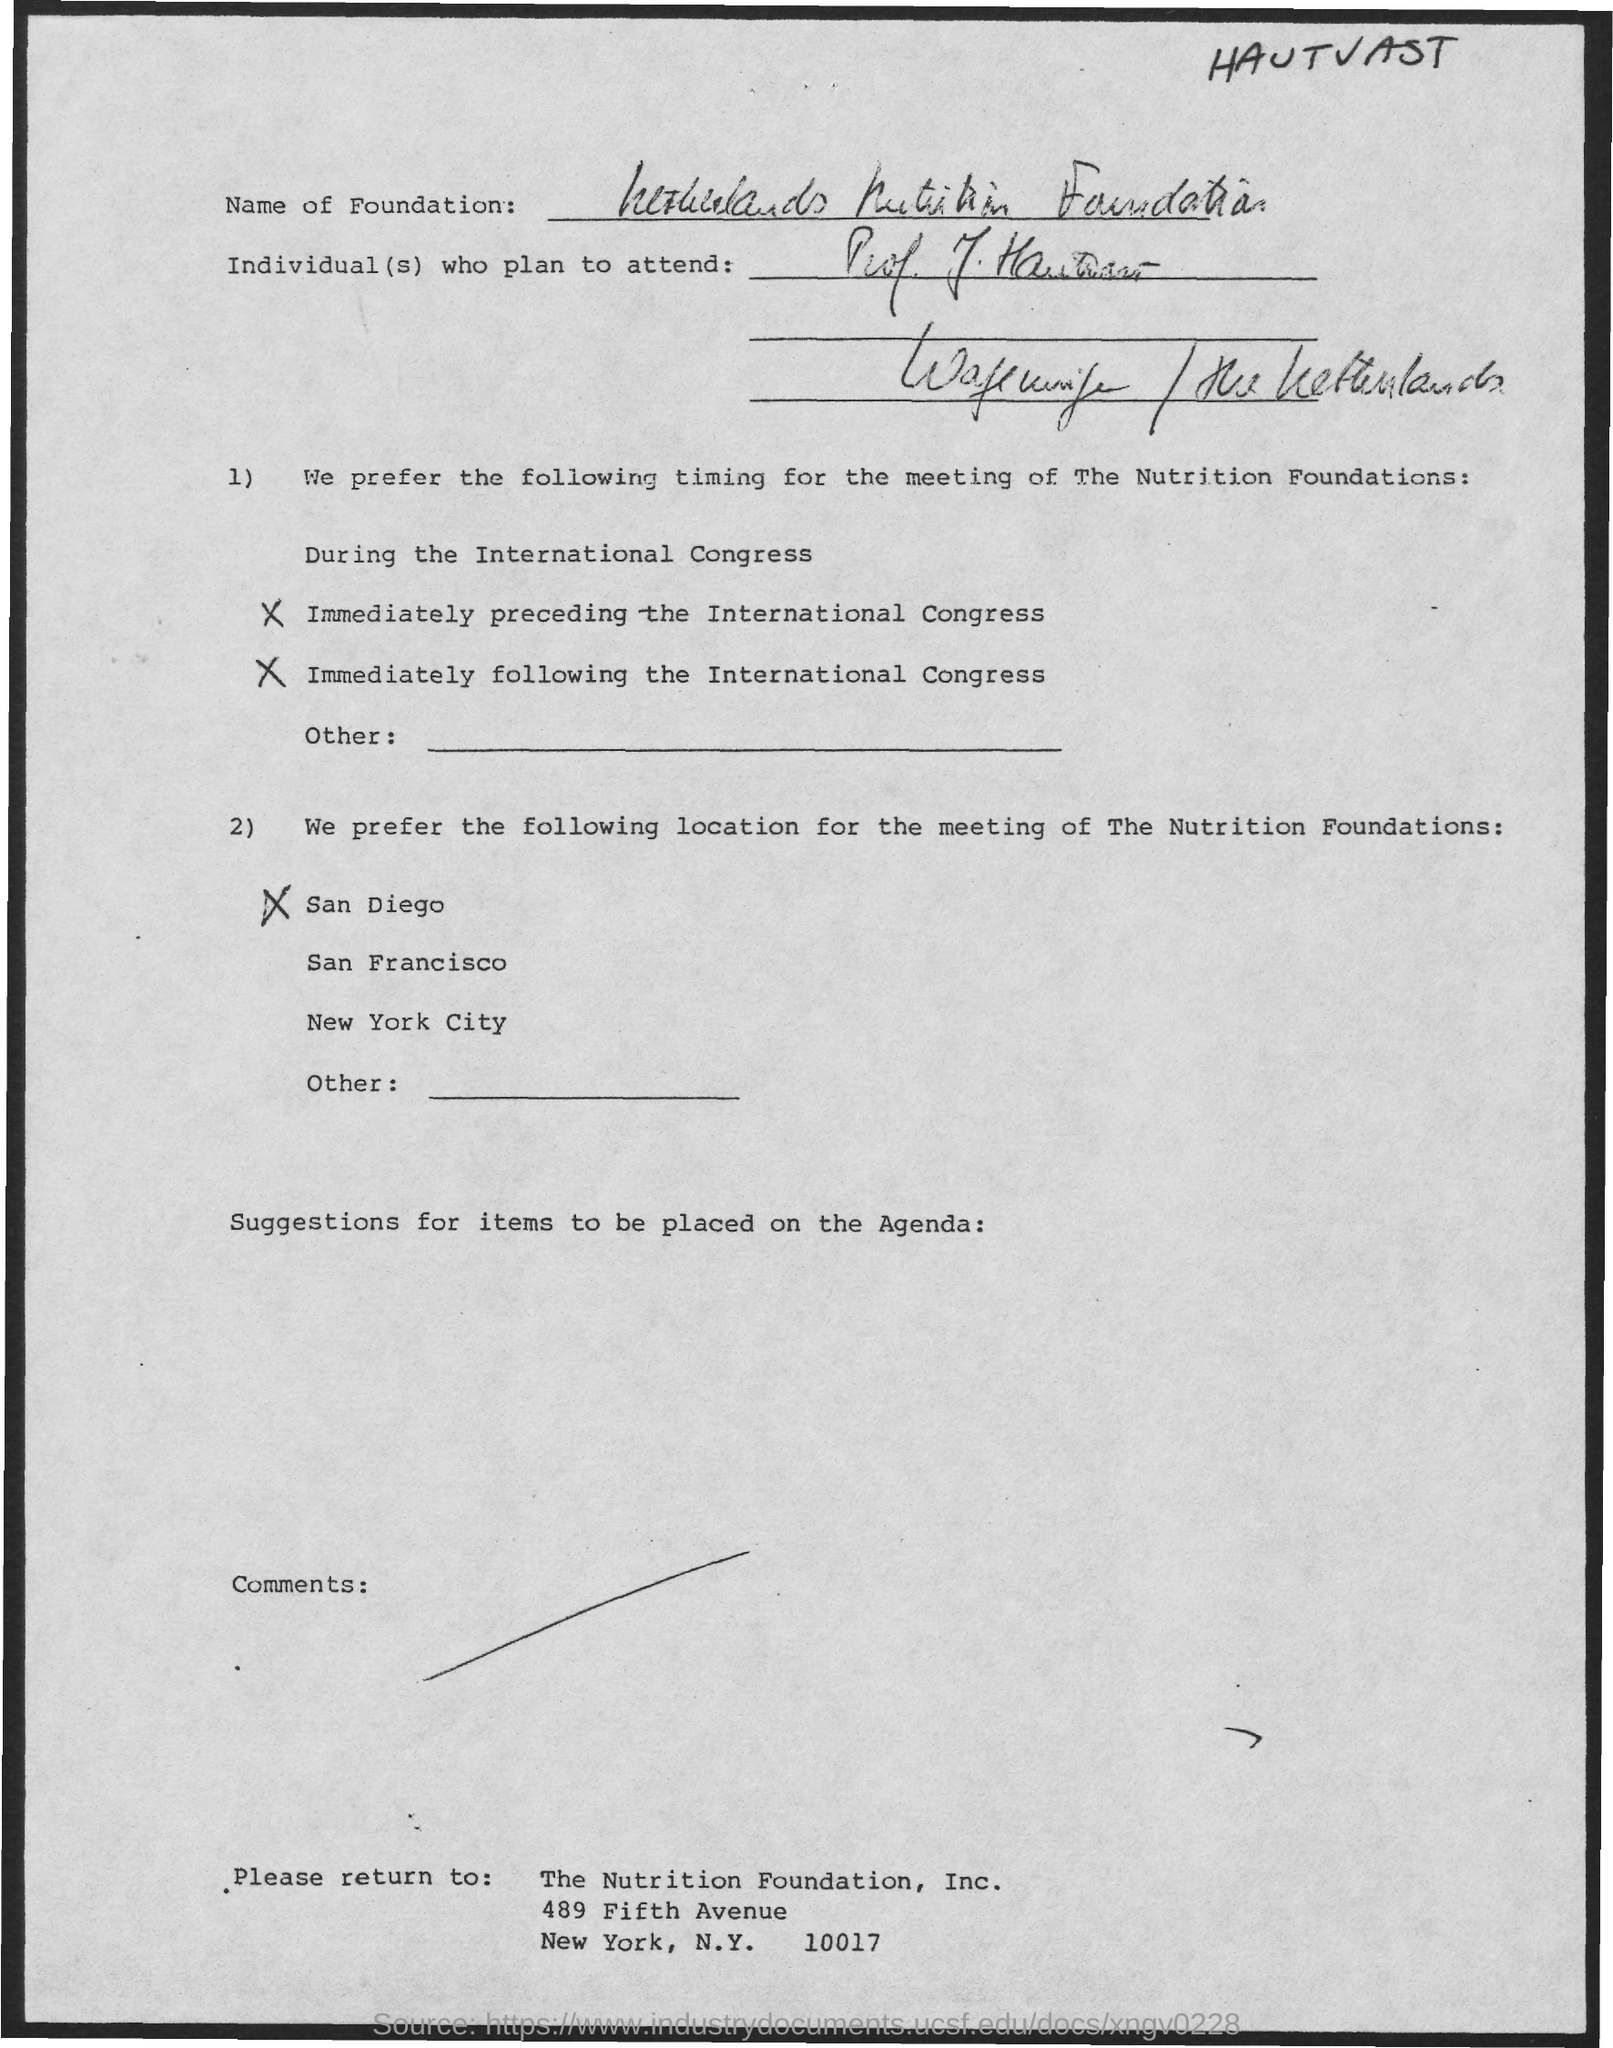To whom this has to be returned ?
Provide a succinct answer. The Nutrition Foundation, Inc. In which city the nutrition foundation , inc is located
Your answer should be very brief. New york. 